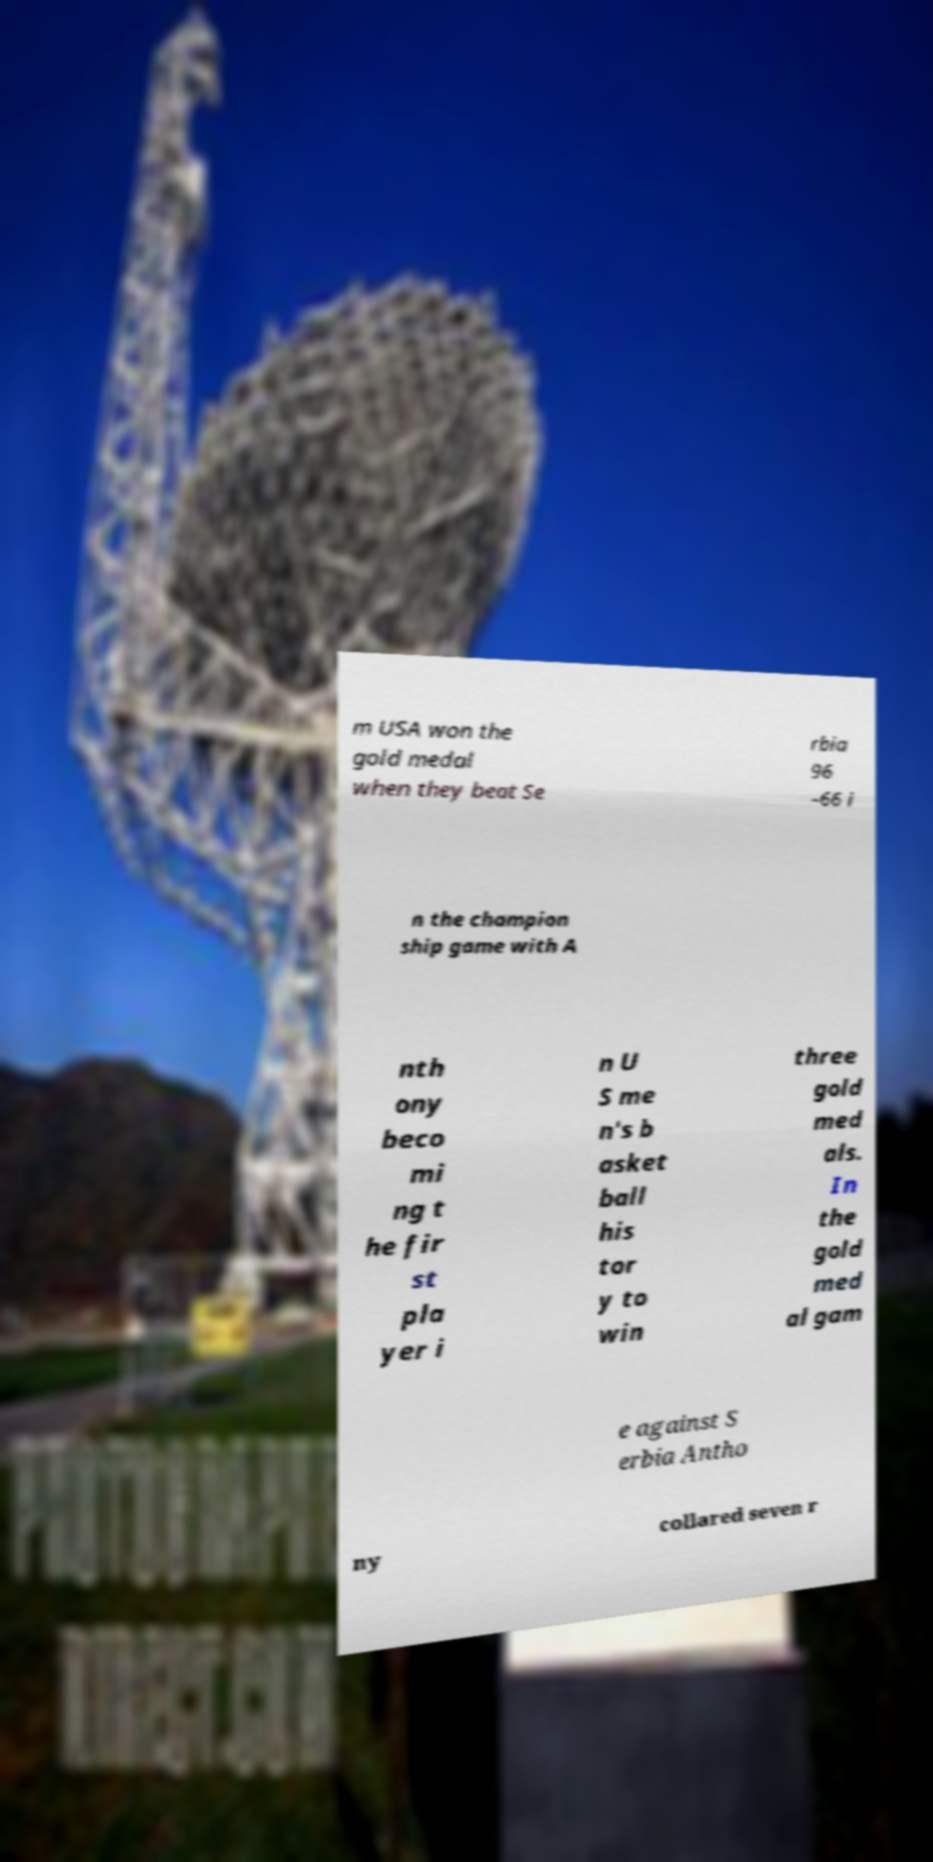Can you read and provide the text displayed in the image?This photo seems to have some interesting text. Can you extract and type it out for me? m USA won the gold medal when they beat Se rbia 96 –66 i n the champion ship game with A nth ony beco mi ng t he fir st pla yer i n U S me n's b asket ball his tor y to win three gold med als. In the gold med al gam e against S erbia Antho ny collared seven r 